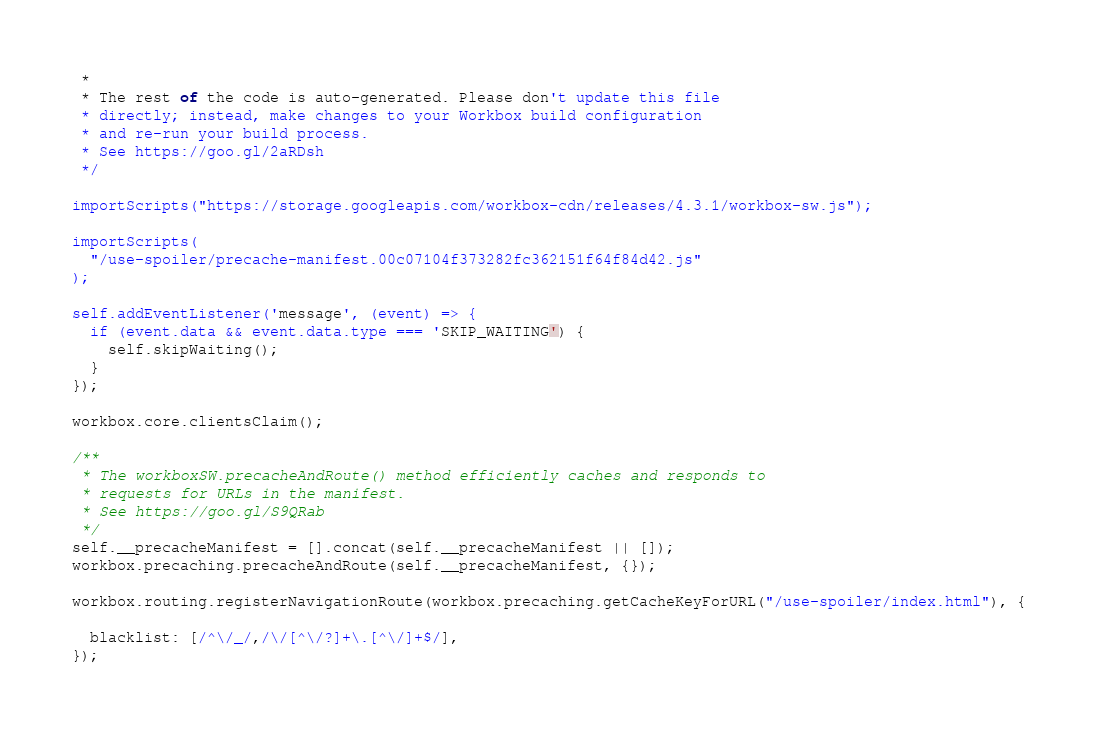Convert code to text. <code><loc_0><loc_0><loc_500><loc_500><_JavaScript_> *
 * The rest of the code is auto-generated. Please don't update this file
 * directly; instead, make changes to your Workbox build configuration
 * and re-run your build process.
 * See https://goo.gl/2aRDsh
 */

importScripts("https://storage.googleapis.com/workbox-cdn/releases/4.3.1/workbox-sw.js");

importScripts(
  "/use-spoiler/precache-manifest.00c07104f373282fc362151f64f84d42.js"
);

self.addEventListener('message', (event) => {
  if (event.data && event.data.type === 'SKIP_WAITING') {
    self.skipWaiting();
  }
});

workbox.core.clientsClaim();

/**
 * The workboxSW.precacheAndRoute() method efficiently caches and responds to
 * requests for URLs in the manifest.
 * See https://goo.gl/S9QRab
 */
self.__precacheManifest = [].concat(self.__precacheManifest || []);
workbox.precaching.precacheAndRoute(self.__precacheManifest, {});

workbox.routing.registerNavigationRoute(workbox.precaching.getCacheKeyForURL("/use-spoiler/index.html"), {
  
  blacklist: [/^\/_/,/\/[^\/?]+\.[^\/]+$/],
});
</code> 